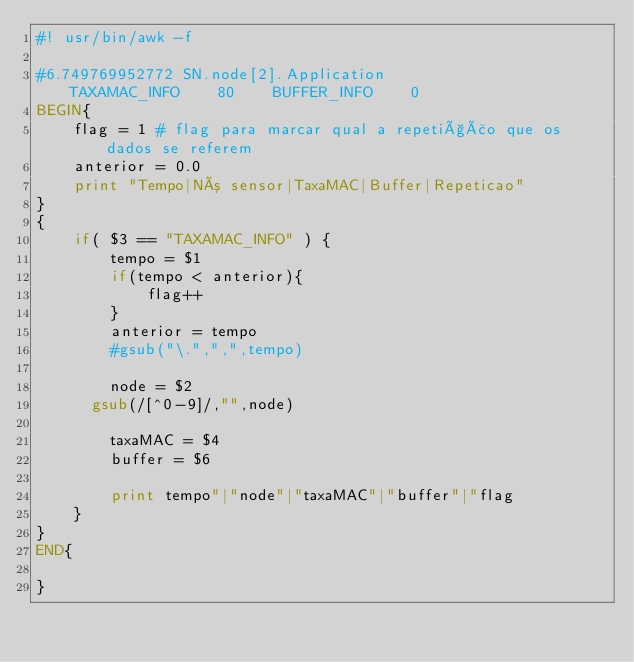<code> <loc_0><loc_0><loc_500><loc_500><_Awk_>#! usr/bin/awk -f

#6.749769952772	SN.node[2].Application                   TAXAMAC_INFO    80    BUFFER_INFO    0
BEGIN{
    flag = 1 # flag para marcar qual a repetição que os dados se referem
    anterior = 0.0
    print "Tempo|Nó sensor|TaxaMAC|Buffer|Repeticao"
}
{
    if( $3 == "TAXAMAC_INFO" ) {
        tempo = $1
        if(tempo < anterior){
            flag++
        }
        anterior = tempo
        #gsub("\.",",",tempo)

        node = $2
	    gsub(/[^0-9]/,"",node)

        taxaMAC = $4
        buffer = $6

        print tempo"|"node"|"taxaMAC"|"buffer"|"flag
    }
}
END{

}</code> 